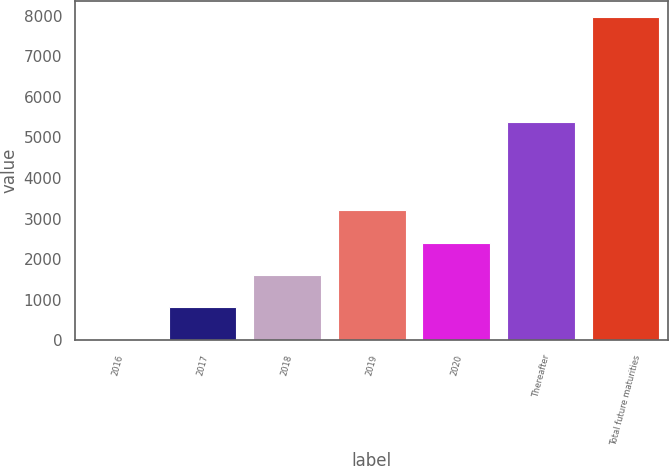Convert chart. <chart><loc_0><loc_0><loc_500><loc_500><bar_chart><fcel>2016<fcel>2017<fcel>2018<fcel>2019<fcel>2020<fcel>Thereafter<fcel>Total future maturities<nl><fcel>20<fcel>815.2<fcel>1610.4<fcel>3200.8<fcel>2405.6<fcel>5381<fcel>7972<nl></chart> 